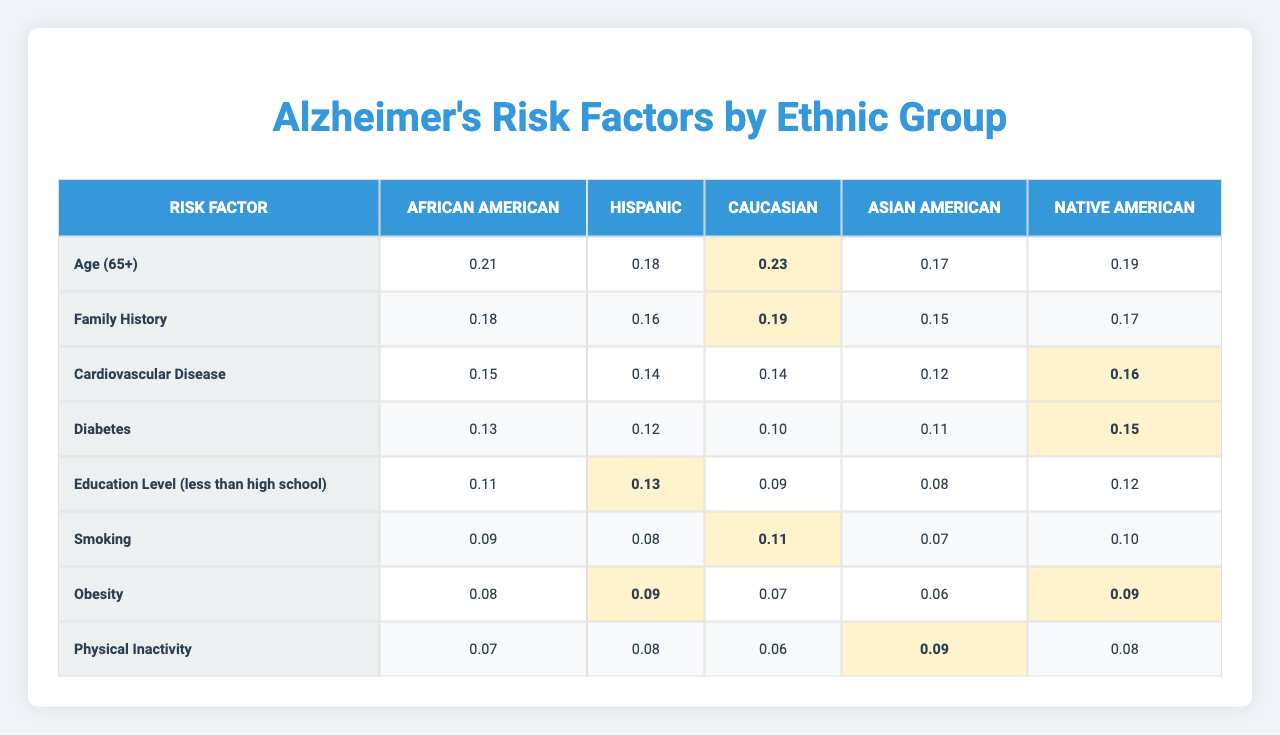What is the highest risk factor for Alzheimer's among Hispanic people? From the table, the highest value for Hispanic is associated with the risk factor 'Family History', which has a value of 0.16.
Answer: Family History Which ethnic group has the highest percentage of individuals aged 65 and older? The table shows that Caucasian individuals have the highest percentage for 'Age (65+)', with a value of 0.23 compared to others.
Answer: Caucasian What is the average risk factor value for 'Diabetes' across all ethnic groups? Summing the 'Diabetes' values (0.13 + 0.12 + 0.10 + 0.11 + 0.15) = 0.61, and dividing by 5 gives an average of 0.122.
Answer: 0.122 Is 'Obesity' a more significant risk factor for Caucasian or Native American individuals? For 'Obesity', Caucasian has a value of 0.07 while Native American has a value of 0.09, indicating it is higher for Native American individuals.
Answer: Native American What is the difference in the value of 'Physical Inactivity' between the ethnic groups with the highest and lowest values? The highest value for 'Physical Inactivity' is found in Asian American (0.09), and the lowest is in Caucasian (0.06). The difference is 0.09 - 0.06 = 0.03.
Answer: 0.03 Which risk factor has the lowest value among African Americans? In the data for African Americans, the lowest value is for 'Physical Inactivity', which is 0.07.
Answer: Physical Inactivity How many risk factors have a higher value in Native Americans compared to Asian Americans? Comparing the values between these groups shows that Native Americans have a higher value for 'Family History', 'Cardiovascular Disease', 'Diabetes', and 'Education Level (less than high school)'. That's a total of 4 risk factors.
Answer: 4 Is the prevalence of cardiovascular disease a significant risk factor among Caucasians compared to African Americans? The value for 'Cardiovascular Disease' in Caucasians is 0.14 and for African Americans is 0.15; therefore, it is not significantly lower for Caucasians.
Answer: No Which ethnic group exhibits the least risk for having a family history of Alzheimer's? The data shows that Asian Americans have the lowest value at 0.15 for 'Family History', compared to other groups.
Answer: Asian American What is the combined value of 'Smoking' and 'Obesity' for Hispanic individuals? The value for 'Smoking' is 0.08 and for 'Obesity' is 0.09. Adding these together gives 0.08 + 0.09 = 0.17.
Answer: 0.17 